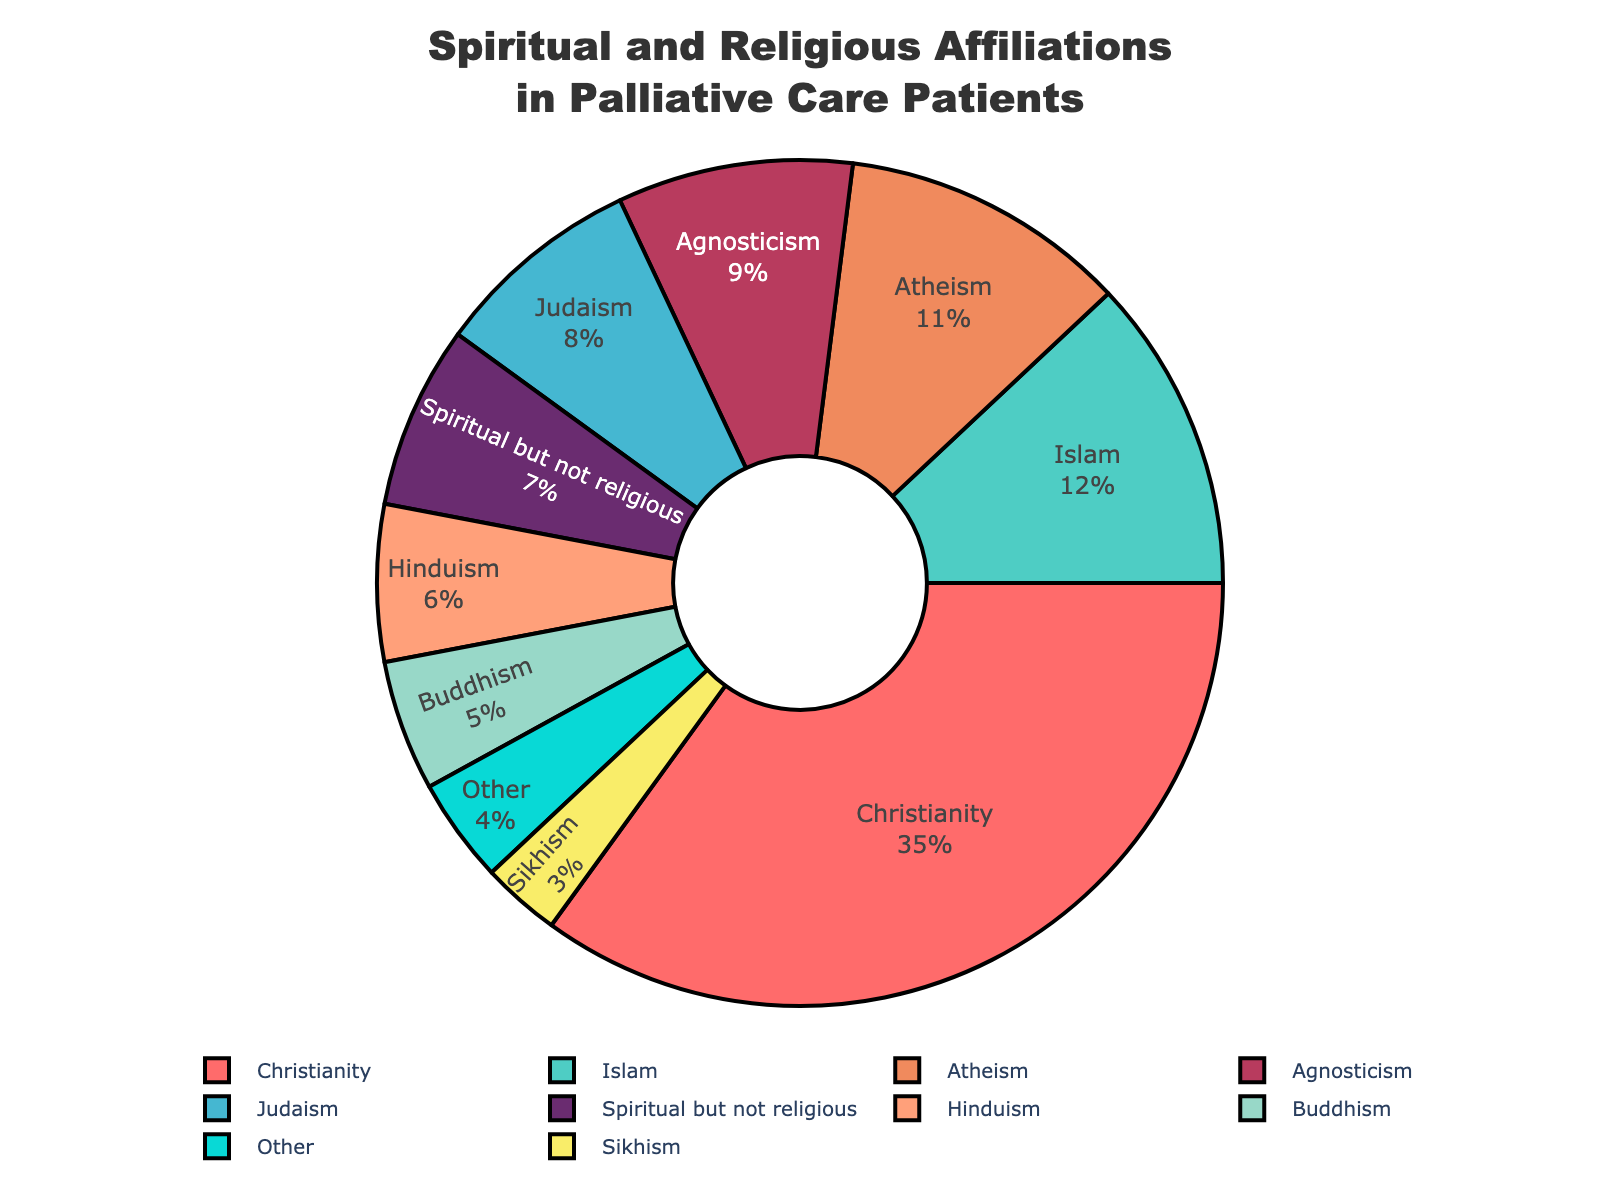Which religious affiliation has the highest percentage among palliative care patients? The slice with the largest percentage on the pie chart represents Christianity with a value of 35%.
Answer: Christianity What is the combined percentage of patients identifying as Atheist and Agnostic? Add the percentages of Atheism (11%) and Agnosticism (9%), i.e., 11 + 9 = 20%.
Answer: 20% How does the percentage of Buddhist patients compare to that of Hindu patients? The percentage for Buddhism is 5%, and for Hinduism, it is 6%. Since 5% is less than 6%, the percentage of Buddhist patients is lower than that of Hindu patients.
Answer: Less Which two groups have a combined percentage of 20%? The pie chart shows that Atheism (11%) and Agnosticism (9%) add up to 20%. The combined total is 11 + 9 = 20.
Answer: Atheism and Agnosticism What is the visual indicator for "Other" in the pie chart? The "Other" category is represented with a section that is labeled "Other" and has a specified percentage (4%).
Answer: A section labeled "Other" Substitute the percentages for Christianity and Islam and determine the difference. Christianity has 35% and Islam has 12%. The difference between them is 35 – 12 = 23%.
Answer: 23% Which category has the smallest representation, and what percentage does it hold? The pie chart indicates that Sikhism has the smallest slice with a percentage of 3%.
Answer: Sikhism, 3% How many religious affiliations have a representation of 7% or higher? We look at the percentages: Christianity (35%), Islam (12%), Judaism (8%), Atheism (11%), Agnosticism (9%), and "Spiritual but not religious" (7%). There are 6 affiliations with 7% or higher.
Answer: 6 What is the total percentage of all religious affiliations in the pie chart? Sum of all category percentages: 35 (Christianity) + 12 (Islam) + 8 (Judaism) + 6 (Hinduism) + 5 (Buddhism) + 3 (Sikhism) + 11 (Atheism) + 9 (Agnosticism) + 7 (Spiritual but not religious) + 4 (Other) = 100%.
Answer: 100% 